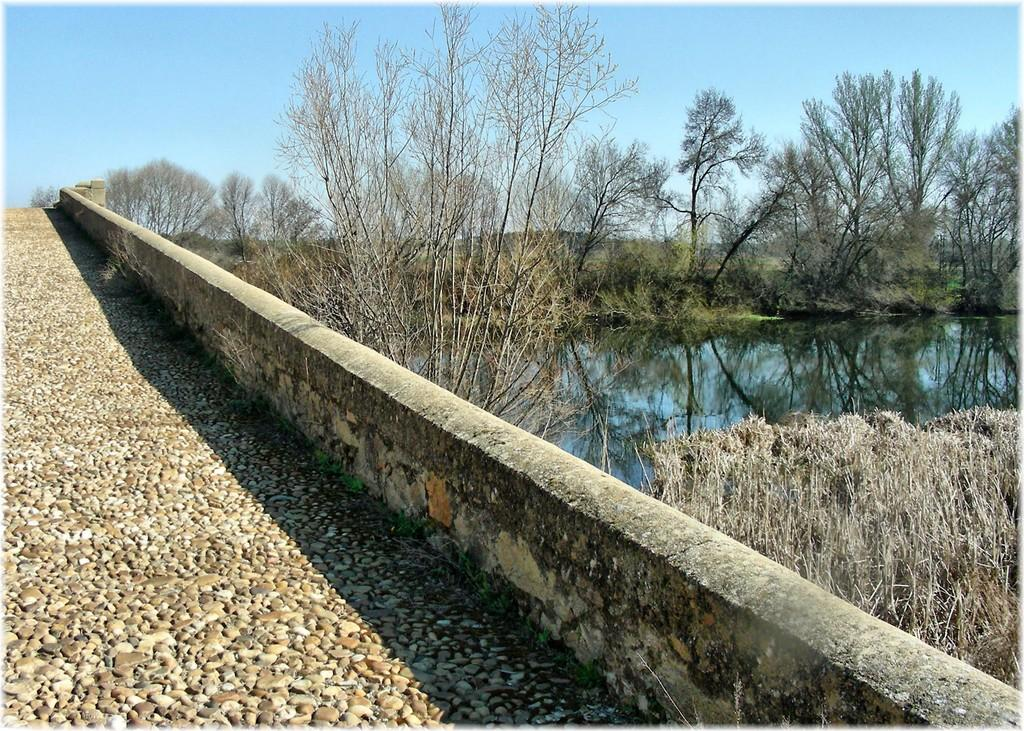What type of structure can be seen in the image? There is a wall in the image. What natural elements are present in the image? There are trees, water, and bushes visible in the image. What part of the sky is visible in the image? The sky is visible in the image. What can be observed in the sky? Clouds are present in the sky. What type of chin can be seen on the trees in the image? There are no chins present in the image, as chins are a feature of humans and animals, not trees. 